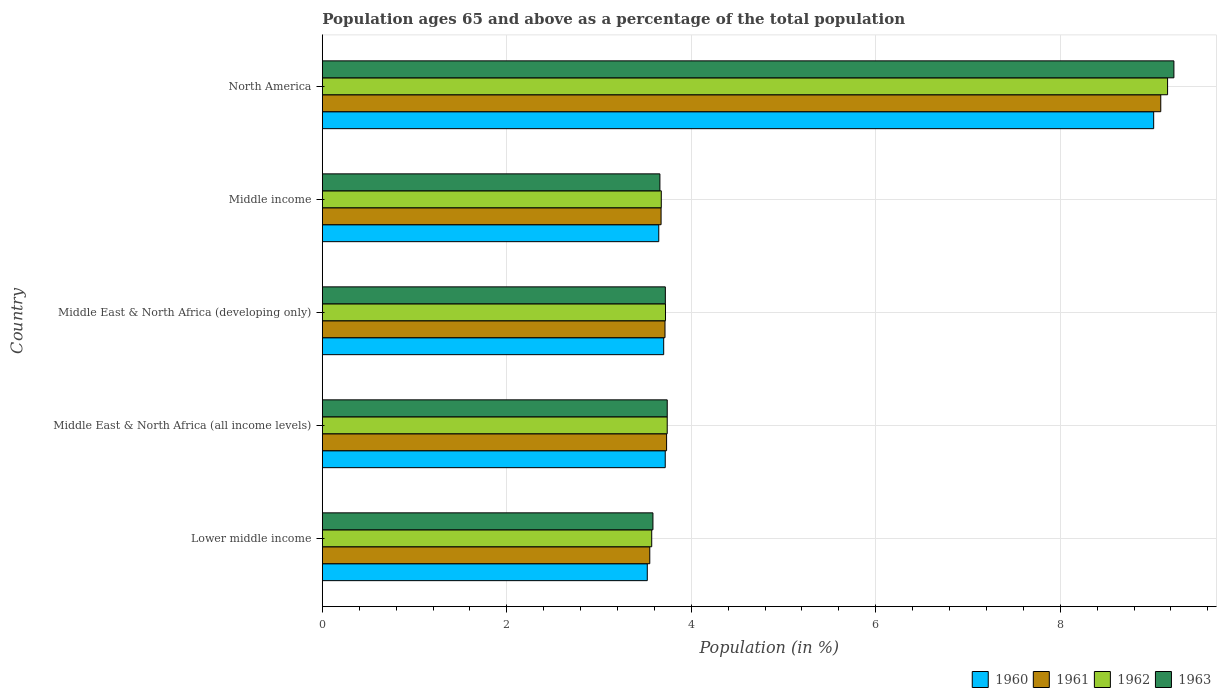How many groups of bars are there?
Keep it short and to the point. 5. Are the number of bars on each tick of the Y-axis equal?
Give a very brief answer. Yes. How many bars are there on the 5th tick from the bottom?
Offer a terse response. 4. What is the label of the 5th group of bars from the top?
Offer a terse response. Lower middle income. What is the percentage of the population ages 65 and above in 1961 in Middle East & North Africa (all income levels)?
Your answer should be compact. 3.73. Across all countries, what is the maximum percentage of the population ages 65 and above in 1961?
Provide a succinct answer. 9.09. Across all countries, what is the minimum percentage of the population ages 65 and above in 1960?
Provide a succinct answer. 3.52. In which country was the percentage of the population ages 65 and above in 1963 minimum?
Your answer should be very brief. Lower middle income. What is the total percentage of the population ages 65 and above in 1960 in the graph?
Provide a short and direct response. 23.6. What is the difference between the percentage of the population ages 65 and above in 1962 in Middle East & North Africa (all income levels) and that in Middle East & North Africa (developing only)?
Offer a very short reply. 0.02. What is the difference between the percentage of the population ages 65 and above in 1960 in Middle East & North Africa (all income levels) and the percentage of the population ages 65 and above in 1963 in Middle income?
Your answer should be very brief. 0.06. What is the average percentage of the population ages 65 and above in 1961 per country?
Offer a very short reply. 4.75. What is the difference between the percentage of the population ages 65 and above in 1962 and percentage of the population ages 65 and above in 1961 in Middle income?
Your response must be concise. 0. In how many countries, is the percentage of the population ages 65 and above in 1961 greater than 7.2 ?
Offer a very short reply. 1. What is the ratio of the percentage of the population ages 65 and above in 1963 in Lower middle income to that in North America?
Offer a very short reply. 0.39. Is the percentage of the population ages 65 and above in 1963 in Middle East & North Africa (all income levels) less than that in North America?
Your response must be concise. Yes. What is the difference between the highest and the second highest percentage of the population ages 65 and above in 1960?
Keep it short and to the point. 5.3. What is the difference between the highest and the lowest percentage of the population ages 65 and above in 1962?
Give a very brief answer. 5.59. In how many countries, is the percentage of the population ages 65 and above in 1962 greater than the average percentage of the population ages 65 and above in 1962 taken over all countries?
Keep it short and to the point. 1. Is the sum of the percentage of the population ages 65 and above in 1963 in Lower middle income and Middle income greater than the maximum percentage of the population ages 65 and above in 1961 across all countries?
Keep it short and to the point. No. Is it the case that in every country, the sum of the percentage of the population ages 65 and above in 1962 and percentage of the population ages 65 and above in 1961 is greater than the sum of percentage of the population ages 65 and above in 1960 and percentage of the population ages 65 and above in 1963?
Ensure brevity in your answer.  No. Are all the bars in the graph horizontal?
Provide a short and direct response. Yes. What is the difference between two consecutive major ticks on the X-axis?
Make the answer very short. 2. Are the values on the major ticks of X-axis written in scientific E-notation?
Make the answer very short. No. Does the graph contain grids?
Ensure brevity in your answer.  Yes. Where does the legend appear in the graph?
Give a very brief answer. Bottom right. How are the legend labels stacked?
Keep it short and to the point. Horizontal. What is the title of the graph?
Ensure brevity in your answer.  Population ages 65 and above as a percentage of the total population. Does "1977" appear as one of the legend labels in the graph?
Keep it short and to the point. No. What is the label or title of the Y-axis?
Offer a terse response. Country. What is the Population (in %) of 1960 in Lower middle income?
Your answer should be compact. 3.52. What is the Population (in %) of 1961 in Lower middle income?
Your response must be concise. 3.55. What is the Population (in %) of 1962 in Lower middle income?
Your answer should be very brief. 3.57. What is the Population (in %) of 1963 in Lower middle income?
Provide a short and direct response. 3.58. What is the Population (in %) of 1960 in Middle East & North Africa (all income levels)?
Offer a very short reply. 3.72. What is the Population (in %) of 1961 in Middle East & North Africa (all income levels)?
Give a very brief answer. 3.73. What is the Population (in %) in 1962 in Middle East & North Africa (all income levels)?
Your response must be concise. 3.74. What is the Population (in %) in 1963 in Middle East & North Africa (all income levels)?
Offer a very short reply. 3.74. What is the Population (in %) of 1960 in Middle East & North Africa (developing only)?
Offer a very short reply. 3.7. What is the Population (in %) of 1961 in Middle East & North Africa (developing only)?
Your answer should be compact. 3.72. What is the Population (in %) in 1962 in Middle East & North Africa (developing only)?
Offer a very short reply. 3.72. What is the Population (in %) in 1963 in Middle East & North Africa (developing only)?
Provide a short and direct response. 3.72. What is the Population (in %) of 1960 in Middle income?
Offer a very short reply. 3.65. What is the Population (in %) in 1961 in Middle income?
Your answer should be very brief. 3.67. What is the Population (in %) of 1962 in Middle income?
Your answer should be compact. 3.67. What is the Population (in %) in 1963 in Middle income?
Provide a succinct answer. 3.66. What is the Population (in %) in 1960 in North America?
Ensure brevity in your answer.  9.01. What is the Population (in %) of 1961 in North America?
Provide a succinct answer. 9.09. What is the Population (in %) of 1962 in North America?
Offer a very short reply. 9.16. What is the Population (in %) of 1963 in North America?
Provide a short and direct response. 9.23. Across all countries, what is the maximum Population (in %) in 1960?
Offer a terse response. 9.01. Across all countries, what is the maximum Population (in %) of 1961?
Provide a succinct answer. 9.09. Across all countries, what is the maximum Population (in %) in 1962?
Ensure brevity in your answer.  9.16. Across all countries, what is the maximum Population (in %) of 1963?
Keep it short and to the point. 9.23. Across all countries, what is the minimum Population (in %) of 1960?
Give a very brief answer. 3.52. Across all countries, what is the minimum Population (in %) of 1961?
Your answer should be compact. 3.55. Across all countries, what is the minimum Population (in %) in 1962?
Your answer should be compact. 3.57. Across all countries, what is the minimum Population (in %) of 1963?
Keep it short and to the point. 3.58. What is the total Population (in %) of 1960 in the graph?
Your response must be concise. 23.6. What is the total Population (in %) in 1961 in the graph?
Your response must be concise. 23.76. What is the total Population (in %) in 1962 in the graph?
Your answer should be very brief. 23.87. What is the total Population (in %) of 1963 in the graph?
Offer a very short reply. 23.93. What is the difference between the Population (in %) in 1960 in Lower middle income and that in Middle East & North Africa (all income levels)?
Your answer should be compact. -0.19. What is the difference between the Population (in %) of 1961 in Lower middle income and that in Middle East & North Africa (all income levels)?
Your answer should be compact. -0.18. What is the difference between the Population (in %) of 1962 in Lower middle income and that in Middle East & North Africa (all income levels)?
Provide a short and direct response. -0.17. What is the difference between the Population (in %) in 1963 in Lower middle income and that in Middle East & North Africa (all income levels)?
Your answer should be compact. -0.16. What is the difference between the Population (in %) of 1960 in Lower middle income and that in Middle East & North Africa (developing only)?
Provide a short and direct response. -0.18. What is the difference between the Population (in %) in 1961 in Lower middle income and that in Middle East & North Africa (developing only)?
Offer a terse response. -0.16. What is the difference between the Population (in %) in 1962 in Lower middle income and that in Middle East & North Africa (developing only)?
Offer a very short reply. -0.15. What is the difference between the Population (in %) in 1963 in Lower middle income and that in Middle East & North Africa (developing only)?
Your answer should be compact. -0.13. What is the difference between the Population (in %) in 1960 in Lower middle income and that in Middle income?
Offer a very short reply. -0.12. What is the difference between the Population (in %) of 1961 in Lower middle income and that in Middle income?
Offer a very short reply. -0.12. What is the difference between the Population (in %) in 1962 in Lower middle income and that in Middle income?
Keep it short and to the point. -0.1. What is the difference between the Population (in %) of 1963 in Lower middle income and that in Middle income?
Your answer should be very brief. -0.08. What is the difference between the Population (in %) in 1960 in Lower middle income and that in North America?
Provide a short and direct response. -5.49. What is the difference between the Population (in %) in 1961 in Lower middle income and that in North America?
Provide a short and direct response. -5.54. What is the difference between the Population (in %) of 1962 in Lower middle income and that in North America?
Your answer should be very brief. -5.59. What is the difference between the Population (in %) in 1963 in Lower middle income and that in North America?
Your response must be concise. -5.65. What is the difference between the Population (in %) of 1960 in Middle East & North Africa (all income levels) and that in Middle East & North Africa (developing only)?
Ensure brevity in your answer.  0.02. What is the difference between the Population (in %) of 1961 in Middle East & North Africa (all income levels) and that in Middle East & North Africa (developing only)?
Make the answer very short. 0.02. What is the difference between the Population (in %) of 1962 in Middle East & North Africa (all income levels) and that in Middle East & North Africa (developing only)?
Your answer should be compact. 0.02. What is the difference between the Population (in %) of 1963 in Middle East & North Africa (all income levels) and that in Middle East & North Africa (developing only)?
Keep it short and to the point. 0.02. What is the difference between the Population (in %) of 1960 in Middle East & North Africa (all income levels) and that in Middle income?
Ensure brevity in your answer.  0.07. What is the difference between the Population (in %) in 1961 in Middle East & North Africa (all income levels) and that in Middle income?
Offer a terse response. 0.06. What is the difference between the Population (in %) in 1962 in Middle East & North Africa (all income levels) and that in Middle income?
Offer a terse response. 0.06. What is the difference between the Population (in %) in 1963 in Middle East & North Africa (all income levels) and that in Middle income?
Your response must be concise. 0.08. What is the difference between the Population (in %) in 1960 in Middle East & North Africa (all income levels) and that in North America?
Your response must be concise. -5.3. What is the difference between the Population (in %) in 1961 in Middle East & North Africa (all income levels) and that in North America?
Keep it short and to the point. -5.36. What is the difference between the Population (in %) in 1962 in Middle East & North Africa (all income levels) and that in North America?
Offer a terse response. -5.42. What is the difference between the Population (in %) of 1963 in Middle East & North Africa (all income levels) and that in North America?
Your response must be concise. -5.49. What is the difference between the Population (in %) of 1960 in Middle East & North Africa (developing only) and that in Middle income?
Ensure brevity in your answer.  0.05. What is the difference between the Population (in %) of 1961 in Middle East & North Africa (developing only) and that in Middle income?
Offer a terse response. 0.04. What is the difference between the Population (in %) of 1962 in Middle East & North Africa (developing only) and that in Middle income?
Provide a succinct answer. 0.05. What is the difference between the Population (in %) in 1963 in Middle East & North Africa (developing only) and that in Middle income?
Provide a succinct answer. 0.06. What is the difference between the Population (in %) in 1960 in Middle East & North Africa (developing only) and that in North America?
Offer a very short reply. -5.31. What is the difference between the Population (in %) of 1961 in Middle East & North Africa (developing only) and that in North America?
Offer a terse response. -5.37. What is the difference between the Population (in %) in 1962 in Middle East & North Africa (developing only) and that in North America?
Offer a terse response. -5.44. What is the difference between the Population (in %) in 1963 in Middle East & North Africa (developing only) and that in North America?
Your answer should be very brief. -5.51. What is the difference between the Population (in %) in 1960 in Middle income and that in North America?
Your answer should be compact. -5.37. What is the difference between the Population (in %) of 1961 in Middle income and that in North America?
Provide a short and direct response. -5.42. What is the difference between the Population (in %) in 1962 in Middle income and that in North America?
Offer a terse response. -5.49. What is the difference between the Population (in %) of 1963 in Middle income and that in North America?
Make the answer very short. -5.57. What is the difference between the Population (in %) in 1960 in Lower middle income and the Population (in %) in 1961 in Middle East & North Africa (all income levels)?
Ensure brevity in your answer.  -0.21. What is the difference between the Population (in %) in 1960 in Lower middle income and the Population (in %) in 1962 in Middle East & North Africa (all income levels)?
Your answer should be very brief. -0.22. What is the difference between the Population (in %) in 1960 in Lower middle income and the Population (in %) in 1963 in Middle East & North Africa (all income levels)?
Give a very brief answer. -0.22. What is the difference between the Population (in %) in 1961 in Lower middle income and the Population (in %) in 1962 in Middle East & North Africa (all income levels)?
Your answer should be very brief. -0.19. What is the difference between the Population (in %) in 1961 in Lower middle income and the Population (in %) in 1963 in Middle East & North Africa (all income levels)?
Provide a succinct answer. -0.19. What is the difference between the Population (in %) of 1962 in Lower middle income and the Population (in %) of 1963 in Middle East & North Africa (all income levels)?
Provide a short and direct response. -0.17. What is the difference between the Population (in %) in 1960 in Lower middle income and the Population (in %) in 1961 in Middle East & North Africa (developing only)?
Give a very brief answer. -0.19. What is the difference between the Population (in %) in 1960 in Lower middle income and the Population (in %) in 1962 in Middle East & North Africa (developing only)?
Offer a terse response. -0.2. What is the difference between the Population (in %) of 1960 in Lower middle income and the Population (in %) of 1963 in Middle East & North Africa (developing only)?
Ensure brevity in your answer.  -0.2. What is the difference between the Population (in %) of 1961 in Lower middle income and the Population (in %) of 1962 in Middle East & North Africa (developing only)?
Offer a very short reply. -0.17. What is the difference between the Population (in %) in 1961 in Lower middle income and the Population (in %) in 1963 in Middle East & North Africa (developing only)?
Your response must be concise. -0.17. What is the difference between the Population (in %) of 1962 in Lower middle income and the Population (in %) of 1963 in Middle East & North Africa (developing only)?
Ensure brevity in your answer.  -0.15. What is the difference between the Population (in %) in 1960 in Lower middle income and the Population (in %) in 1961 in Middle income?
Your response must be concise. -0.15. What is the difference between the Population (in %) of 1960 in Lower middle income and the Population (in %) of 1962 in Middle income?
Your answer should be compact. -0.15. What is the difference between the Population (in %) of 1960 in Lower middle income and the Population (in %) of 1963 in Middle income?
Offer a very short reply. -0.14. What is the difference between the Population (in %) of 1961 in Lower middle income and the Population (in %) of 1962 in Middle income?
Give a very brief answer. -0.12. What is the difference between the Population (in %) in 1961 in Lower middle income and the Population (in %) in 1963 in Middle income?
Give a very brief answer. -0.11. What is the difference between the Population (in %) of 1962 in Lower middle income and the Population (in %) of 1963 in Middle income?
Keep it short and to the point. -0.09. What is the difference between the Population (in %) of 1960 in Lower middle income and the Population (in %) of 1961 in North America?
Your answer should be compact. -5.57. What is the difference between the Population (in %) of 1960 in Lower middle income and the Population (in %) of 1962 in North America?
Ensure brevity in your answer.  -5.64. What is the difference between the Population (in %) of 1960 in Lower middle income and the Population (in %) of 1963 in North America?
Offer a terse response. -5.71. What is the difference between the Population (in %) of 1961 in Lower middle income and the Population (in %) of 1962 in North America?
Provide a short and direct response. -5.61. What is the difference between the Population (in %) in 1961 in Lower middle income and the Population (in %) in 1963 in North America?
Offer a very short reply. -5.68. What is the difference between the Population (in %) of 1962 in Lower middle income and the Population (in %) of 1963 in North America?
Offer a very short reply. -5.66. What is the difference between the Population (in %) of 1960 in Middle East & North Africa (all income levels) and the Population (in %) of 1961 in Middle East & North Africa (developing only)?
Provide a short and direct response. 0. What is the difference between the Population (in %) of 1960 in Middle East & North Africa (all income levels) and the Population (in %) of 1962 in Middle East & North Africa (developing only)?
Your answer should be very brief. -0. What is the difference between the Population (in %) in 1960 in Middle East & North Africa (all income levels) and the Population (in %) in 1963 in Middle East & North Africa (developing only)?
Your answer should be compact. -0. What is the difference between the Population (in %) in 1961 in Middle East & North Africa (all income levels) and the Population (in %) in 1962 in Middle East & North Africa (developing only)?
Ensure brevity in your answer.  0.01. What is the difference between the Population (in %) in 1961 in Middle East & North Africa (all income levels) and the Population (in %) in 1963 in Middle East & North Africa (developing only)?
Make the answer very short. 0.01. What is the difference between the Population (in %) of 1962 in Middle East & North Africa (all income levels) and the Population (in %) of 1963 in Middle East & North Africa (developing only)?
Give a very brief answer. 0.02. What is the difference between the Population (in %) of 1960 in Middle East & North Africa (all income levels) and the Population (in %) of 1961 in Middle income?
Your answer should be very brief. 0.04. What is the difference between the Population (in %) of 1960 in Middle East & North Africa (all income levels) and the Population (in %) of 1962 in Middle income?
Your response must be concise. 0.04. What is the difference between the Population (in %) of 1960 in Middle East & North Africa (all income levels) and the Population (in %) of 1963 in Middle income?
Provide a short and direct response. 0.06. What is the difference between the Population (in %) in 1961 in Middle East & North Africa (all income levels) and the Population (in %) in 1962 in Middle income?
Ensure brevity in your answer.  0.06. What is the difference between the Population (in %) in 1961 in Middle East & North Africa (all income levels) and the Population (in %) in 1963 in Middle income?
Provide a short and direct response. 0.07. What is the difference between the Population (in %) of 1962 in Middle East & North Africa (all income levels) and the Population (in %) of 1963 in Middle income?
Provide a succinct answer. 0.08. What is the difference between the Population (in %) of 1960 in Middle East & North Africa (all income levels) and the Population (in %) of 1961 in North America?
Ensure brevity in your answer.  -5.37. What is the difference between the Population (in %) of 1960 in Middle East & North Africa (all income levels) and the Population (in %) of 1962 in North America?
Ensure brevity in your answer.  -5.45. What is the difference between the Population (in %) in 1960 in Middle East & North Africa (all income levels) and the Population (in %) in 1963 in North America?
Provide a short and direct response. -5.51. What is the difference between the Population (in %) of 1961 in Middle East & North Africa (all income levels) and the Population (in %) of 1962 in North America?
Provide a succinct answer. -5.43. What is the difference between the Population (in %) of 1961 in Middle East & North Africa (all income levels) and the Population (in %) of 1963 in North America?
Your answer should be compact. -5.5. What is the difference between the Population (in %) of 1962 in Middle East & North Africa (all income levels) and the Population (in %) of 1963 in North America?
Offer a very short reply. -5.49. What is the difference between the Population (in %) in 1960 in Middle East & North Africa (developing only) and the Population (in %) in 1961 in Middle income?
Your answer should be very brief. 0.03. What is the difference between the Population (in %) in 1960 in Middle East & North Africa (developing only) and the Population (in %) in 1962 in Middle income?
Your response must be concise. 0.03. What is the difference between the Population (in %) of 1960 in Middle East & North Africa (developing only) and the Population (in %) of 1963 in Middle income?
Offer a very short reply. 0.04. What is the difference between the Population (in %) of 1961 in Middle East & North Africa (developing only) and the Population (in %) of 1962 in Middle income?
Provide a short and direct response. 0.04. What is the difference between the Population (in %) in 1961 in Middle East & North Africa (developing only) and the Population (in %) in 1963 in Middle income?
Keep it short and to the point. 0.06. What is the difference between the Population (in %) in 1962 in Middle East & North Africa (developing only) and the Population (in %) in 1963 in Middle income?
Keep it short and to the point. 0.06. What is the difference between the Population (in %) of 1960 in Middle East & North Africa (developing only) and the Population (in %) of 1961 in North America?
Offer a very short reply. -5.39. What is the difference between the Population (in %) in 1960 in Middle East & North Africa (developing only) and the Population (in %) in 1962 in North America?
Provide a short and direct response. -5.46. What is the difference between the Population (in %) in 1960 in Middle East & North Africa (developing only) and the Population (in %) in 1963 in North America?
Ensure brevity in your answer.  -5.53. What is the difference between the Population (in %) of 1961 in Middle East & North Africa (developing only) and the Population (in %) of 1962 in North America?
Your answer should be very brief. -5.45. What is the difference between the Population (in %) in 1961 in Middle East & North Africa (developing only) and the Population (in %) in 1963 in North America?
Provide a succinct answer. -5.52. What is the difference between the Population (in %) of 1962 in Middle East & North Africa (developing only) and the Population (in %) of 1963 in North America?
Keep it short and to the point. -5.51. What is the difference between the Population (in %) in 1960 in Middle income and the Population (in %) in 1961 in North America?
Your answer should be compact. -5.44. What is the difference between the Population (in %) of 1960 in Middle income and the Population (in %) of 1962 in North America?
Provide a succinct answer. -5.52. What is the difference between the Population (in %) of 1960 in Middle income and the Population (in %) of 1963 in North America?
Make the answer very short. -5.58. What is the difference between the Population (in %) in 1961 in Middle income and the Population (in %) in 1962 in North America?
Provide a succinct answer. -5.49. What is the difference between the Population (in %) of 1961 in Middle income and the Population (in %) of 1963 in North America?
Give a very brief answer. -5.56. What is the difference between the Population (in %) in 1962 in Middle income and the Population (in %) in 1963 in North America?
Your answer should be very brief. -5.56. What is the average Population (in %) of 1960 per country?
Offer a terse response. 4.72. What is the average Population (in %) of 1961 per country?
Provide a succinct answer. 4.75. What is the average Population (in %) of 1962 per country?
Keep it short and to the point. 4.77. What is the average Population (in %) in 1963 per country?
Your answer should be very brief. 4.79. What is the difference between the Population (in %) of 1960 and Population (in %) of 1961 in Lower middle income?
Your answer should be very brief. -0.03. What is the difference between the Population (in %) of 1960 and Population (in %) of 1962 in Lower middle income?
Ensure brevity in your answer.  -0.05. What is the difference between the Population (in %) in 1960 and Population (in %) in 1963 in Lower middle income?
Your response must be concise. -0.06. What is the difference between the Population (in %) in 1961 and Population (in %) in 1962 in Lower middle income?
Your answer should be very brief. -0.02. What is the difference between the Population (in %) of 1961 and Population (in %) of 1963 in Lower middle income?
Offer a very short reply. -0.03. What is the difference between the Population (in %) in 1962 and Population (in %) in 1963 in Lower middle income?
Provide a short and direct response. -0.01. What is the difference between the Population (in %) in 1960 and Population (in %) in 1961 in Middle East & North Africa (all income levels)?
Your answer should be very brief. -0.01. What is the difference between the Population (in %) in 1960 and Population (in %) in 1962 in Middle East & North Africa (all income levels)?
Ensure brevity in your answer.  -0.02. What is the difference between the Population (in %) of 1960 and Population (in %) of 1963 in Middle East & North Africa (all income levels)?
Your response must be concise. -0.02. What is the difference between the Population (in %) of 1961 and Population (in %) of 1962 in Middle East & North Africa (all income levels)?
Provide a short and direct response. -0.01. What is the difference between the Population (in %) of 1961 and Population (in %) of 1963 in Middle East & North Africa (all income levels)?
Your answer should be compact. -0.01. What is the difference between the Population (in %) in 1962 and Population (in %) in 1963 in Middle East & North Africa (all income levels)?
Offer a very short reply. -0. What is the difference between the Population (in %) in 1960 and Population (in %) in 1961 in Middle East & North Africa (developing only)?
Offer a terse response. -0.01. What is the difference between the Population (in %) in 1960 and Population (in %) in 1962 in Middle East & North Africa (developing only)?
Make the answer very short. -0.02. What is the difference between the Population (in %) of 1960 and Population (in %) of 1963 in Middle East & North Africa (developing only)?
Your answer should be very brief. -0.02. What is the difference between the Population (in %) of 1961 and Population (in %) of 1962 in Middle East & North Africa (developing only)?
Offer a very short reply. -0.01. What is the difference between the Population (in %) in 1961 and Population (in %) in 1963 in Middle East & North Africa (developing only)?
Your answer should be compact. -0. What is the difference between the Population (in %) of 1962 and Population (in %) of 1963 in Middle East & North Africa (developing only)?
Ensure brevity in your answer.  0. What is the difference between the Population (in %) in 1960 and Population (in %) in 1961 in Middle income?
Provide a short and direct response. -0.03. What is the difference between the Population (in %) of 1960 and Population (in %) of 1962 in Middle income?
Offer a terse response. -0.03. What is the difference between the Population (in %) in 1960 and Population (in %) in 1963 in Middle income?
Ensure brevity in your answer.  -0.01. What is the difference between the Population (in %) in 1961 and Population (in %) in 1962 in Middle income?
Give a very brief answer. -0. What is the difference between the Population (in %) in 1961 and Population (in %) in 1963 in Middle income?
Offer a terse response. 0.01. What is the difference between the Population (in %) in 1962 and Population (in %) in 1963 in Middle income?
Offer a terse response. 0.01. What is the difference between the Population (in %) of 1960 and Population (in %) of 1961 in North America?
Provide a short and direct response. -0.08. What is the difference between the Population (in %) of 1960 and Population (in %) of 1962 in North America?
Your answer should be compact. -0.15. What is the difference between the Population (in %) of 1960 and Population (in %) of 1963 in North America?
Ensure brevity in your answer.  -0.22. What is the difference between the Population (in %) in 1961 and Population (in %) in 1962 in North America?
Your answer should be compact. -0.07. What is the difference between the Population (in %) of 1961 and Population (in %) of 1963 in North America?
Your response must be concise. -0.14. What is the difference between the Population (in %) in 1962 and Population (in %) in 1963 in North America?
Provide a short and direct response. -0.07. What is the ratio of the Population (in %) in 1960 in Lower middle income to that in Middle East & North Africa (all income levels)?
Offer a very short reply. 0.95. What is the ratio of the Population (in %) of 1961 in Lower middle income to that in Middle East & North Africa (all income levels)?
Keep it short and to the point. 0.95. What is the ratio of the Population (in %) of 1962 in Lower middle income to that in Middle East & North Africa (all income levels)?
Your answer should be very brief. 0.95. What is the ratio of the Population (in %) of 1963 in Lower middle income to that in Middle East & North Africa (all income levels)?
Your response must be concise. 0.96. What is the ratio of the Population (in %) in 1960 in Lower middle income to that in Middle East & North Africa (developing only)?
Keep it short and to the point. 0.95. What is the ratio of the Population (in %) in 1961 in Lower middle income to that in Middle East & North Africa (developing only)?
Make the answer very short. 0.96. What is the ratio of the Population (in %) in 1962 in Lower middle income to that in Middle East & North Africa (developing only)?
Offer a very short reply. 0.96. What is the ratio of the Population (in %) of 1963 in Lower middle income to that in Middle East & North Africa (developing only)?
Provide a succinct answer. 0.96. What is the ratio of the Population (in %) in 1960 in Lower middle income to that in Middle income?
Ensure brevity in your answer.  0.97. What is the ratio of the Population (in %) in 1961 in Lower middle income to that in Middle income?
Your response must be concise. 0.97. What is the ratio of the Population (in %) in 1962 in Lower middle income to that in Middle income?
Provide a succinct answer. 0.97. What is the ratio of the Population (in %) of 1963 in Lower middle income to that in Middle income?
Offer a very short reply. 0.98. What is the ratio of the Population (in %) of 1960 in Lower middle income to that in North America?
Your answer should be very brief. 0.39. What is the ratio of the Population (in %) in 1961 in Lower middle income to that in North America?
Ensure brevity in your answer.  0.39. What is the ratio of the Population (in %) of 1962 in Lower middle income to that in North America?
Provide a succinct answer. 0.39. What is the ratio of the Population (in %) of 1963 in Lower middle income to that in North America?
Provide a short and direct response. 0.39. What is the ratio of the Population (in %) of 1960 in Middle East & North Africa (all income levels) to that in Middle income?
Give a very brief answer. 1.02. What is the ratio of the Population (in %) in 1961 in Middle East & North Africa (all income levels) to that in Middle income?
Offer a terse response. 1.02. What is the ratio of the Population (in %) of 1962 in Middle East & North Africa (all income levels) to that in Middle income?
Give a very brief answer. 1.02. What is the ratio of the Population (in %) of 1963 in Middle East & North Africa (all income levels) to that in Middle income?
Provide a short and direct response. 1.02. What is the ratio of the Population (in %) in 1960 in Middle East & North Africa (all income levels) to that in North America?
Provide a succinct answer. 0.41. What is the ratio of the Population (in %) in 1961 in Middle East & North Africa (all income levels) to that in North America?
Provide a short and direct response. 0.41. What is the ratio of the Population (in %) in 1962 in Middle East & North Africa (all income levels) to that in North America?
Your answer should be very brief. 0.41. What is the ratio of the Population (in %) in 1963 in Middle East & North Africa (all income levels) to that in North America?
Ensure brevity in your answer.  0.41. What is the ratio of the Population (in %) in 1960 in Middle East & North Africa (developing only) to that in Middle income?
Make the answer very short. 1.01. What is the ratio of the Population (in %) of 1961 in Middle East & North Africa (developing only) to that in Middle income?
Give a very brief answer. 1.01. What is the ratio of the Population (in %) of 1962 in Middle East & North Africa (developing only) to that in Middle income?
Ensure brevity in your answer.  1.01. What is the ratio of the Population (in %) of 1963 in Middle East & North Africa (developing only) to that in Middle income?
Offer a very short reply. 1.02. What is the ratio of the Population (in %) of 1960 in Middle East & North Africa (developing only) to that in North America?
Keep it short and to the point. 0.41. What is the ratio of the Population (in %) in 1961 in Middle East & North Africa (developing only) to that in North America?
Ensure brevity in your answer.  0.41. What is the ratio of the Population (in %) in 1962 in Middle East & North Africa (developing only) to that in North America?
Your answer should be very brief. 0.41. What is the ratio of the Population (in %) in 1963 in Middle East & North Africa (developing only) to that in North America?
Your answer should be compact. 0.4. What is the ratio of the Population (in %) of 1960 in Middle income to that in North America?
Ensure brevity in your answer.  0.4. What is the ratio of the Population (in %) in 1961 in Middle income to that in North America?
Your answer should be compact. 0.4. What is the ratio of the Population (in %) of 1962 in Middle income to that in North America?
Provide a succinct answer. 0.4. What is the ratio of the Population (in %) in 1963 in Middle income to that in North America?
Keep it short and to the point. 0.4. What is the difference between the highest and the second highest Population (in %) in 1960?
Your answer should be compact. 5.3. What is the difference between the highest and the second highest Population (in %) of 1961?
Give a very brief answer. 5.36. What is the difference between the highest and the second highest Population (in %) in 1962?
Provide a succinct answer. 5.42. What is the difference between the highest and the second highest Population (in %) in 1963?
Your response must be concise. 5.49. What is the difference between the highest and the lowest Population (in %) of 1960?
Keep it short and to the point. 5.49. What is the difference between the highest and the lowest Population (in %) in 1961?
Provide a succinct answer. 5.54. What is the difference between the highest and the lowest Population (in %) in 1962?
Give a very brief answer. 5.59. What is the difference between the highest and the lowest Population (in %) of 1963?
Provide a succinct answer. 5.65. 